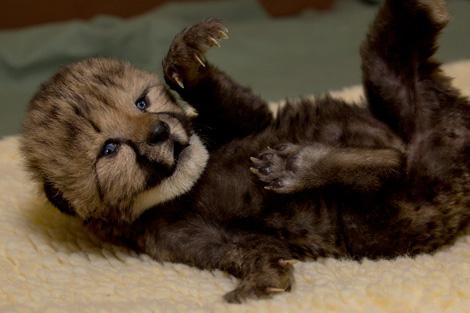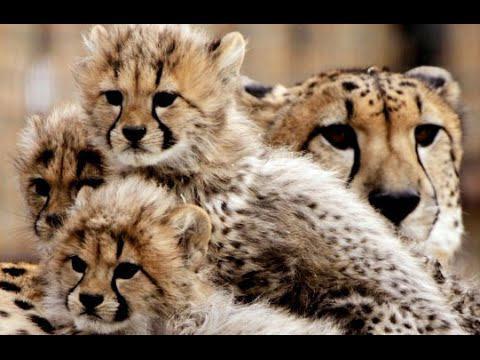The first image is the image on the left, the second image is the image on the right. Examine the images to the left and right. Is the description "All of the animals shown are spotted wild kittens, and one image shows a group of wild kittens without fully open eyes in a pile on straw." accurate? Answer yes or no. No. The first image is the image on the left, the second image is the image on the right. For the images shown, is this caption "In the image to the left, we see three kittens; the young of big cat breeds." true? Answer yes or no. No. 